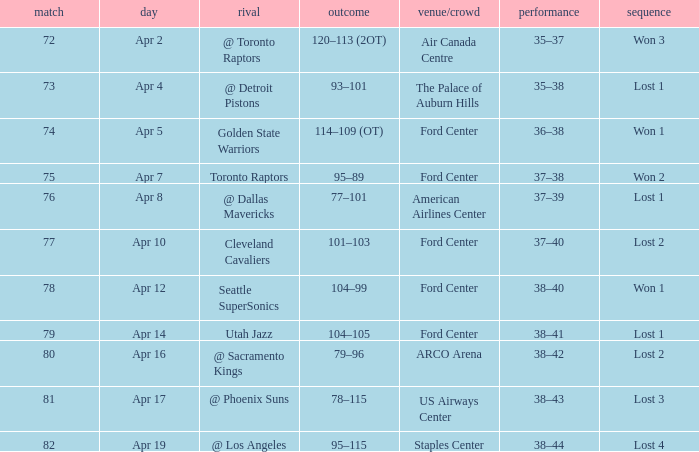Who was the opponent for game 75? Toronto Raptors. 